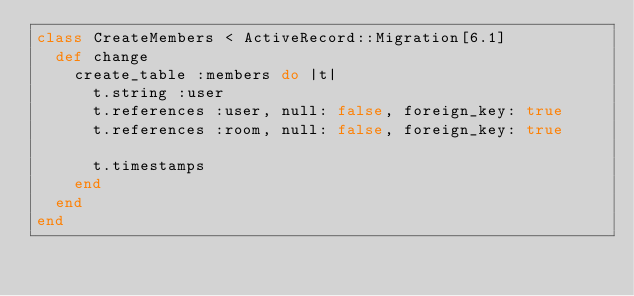<code> <loc_0><loc_0><loc_500><loc_500><_Ruby_>class CreateMembers < ActiveRecord::Migration[6.1]
  def change
    create_table :members do |t|
      t.string :user
      t.references :user, null: false, foreign_key: true
      t.references :room, null: false, foreign_key: true

      t.timestamps
    end
  end
end
</code> 